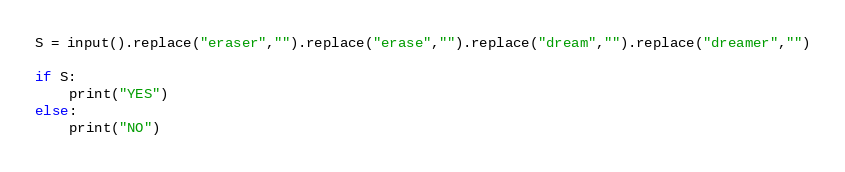<code> <loc_0><loc_0><loc_500><loc_500><_Python_>S = input().replace("eraser","").replace("erase","").replace("dream","").replace("dreamer","")

if S:
    print("YES")
else:
    print("NO")</code> 